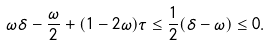Convert formula to latex. <formula><loc_0><loc_0><loc_500><loc_500>\omega \delta - \frac { \omega } { 2 } + ( 1 - 2 \omega ) \tau \leq \frac { 1 } { 2 } ( \delta - \omega ) \leq 0 .</formula> 